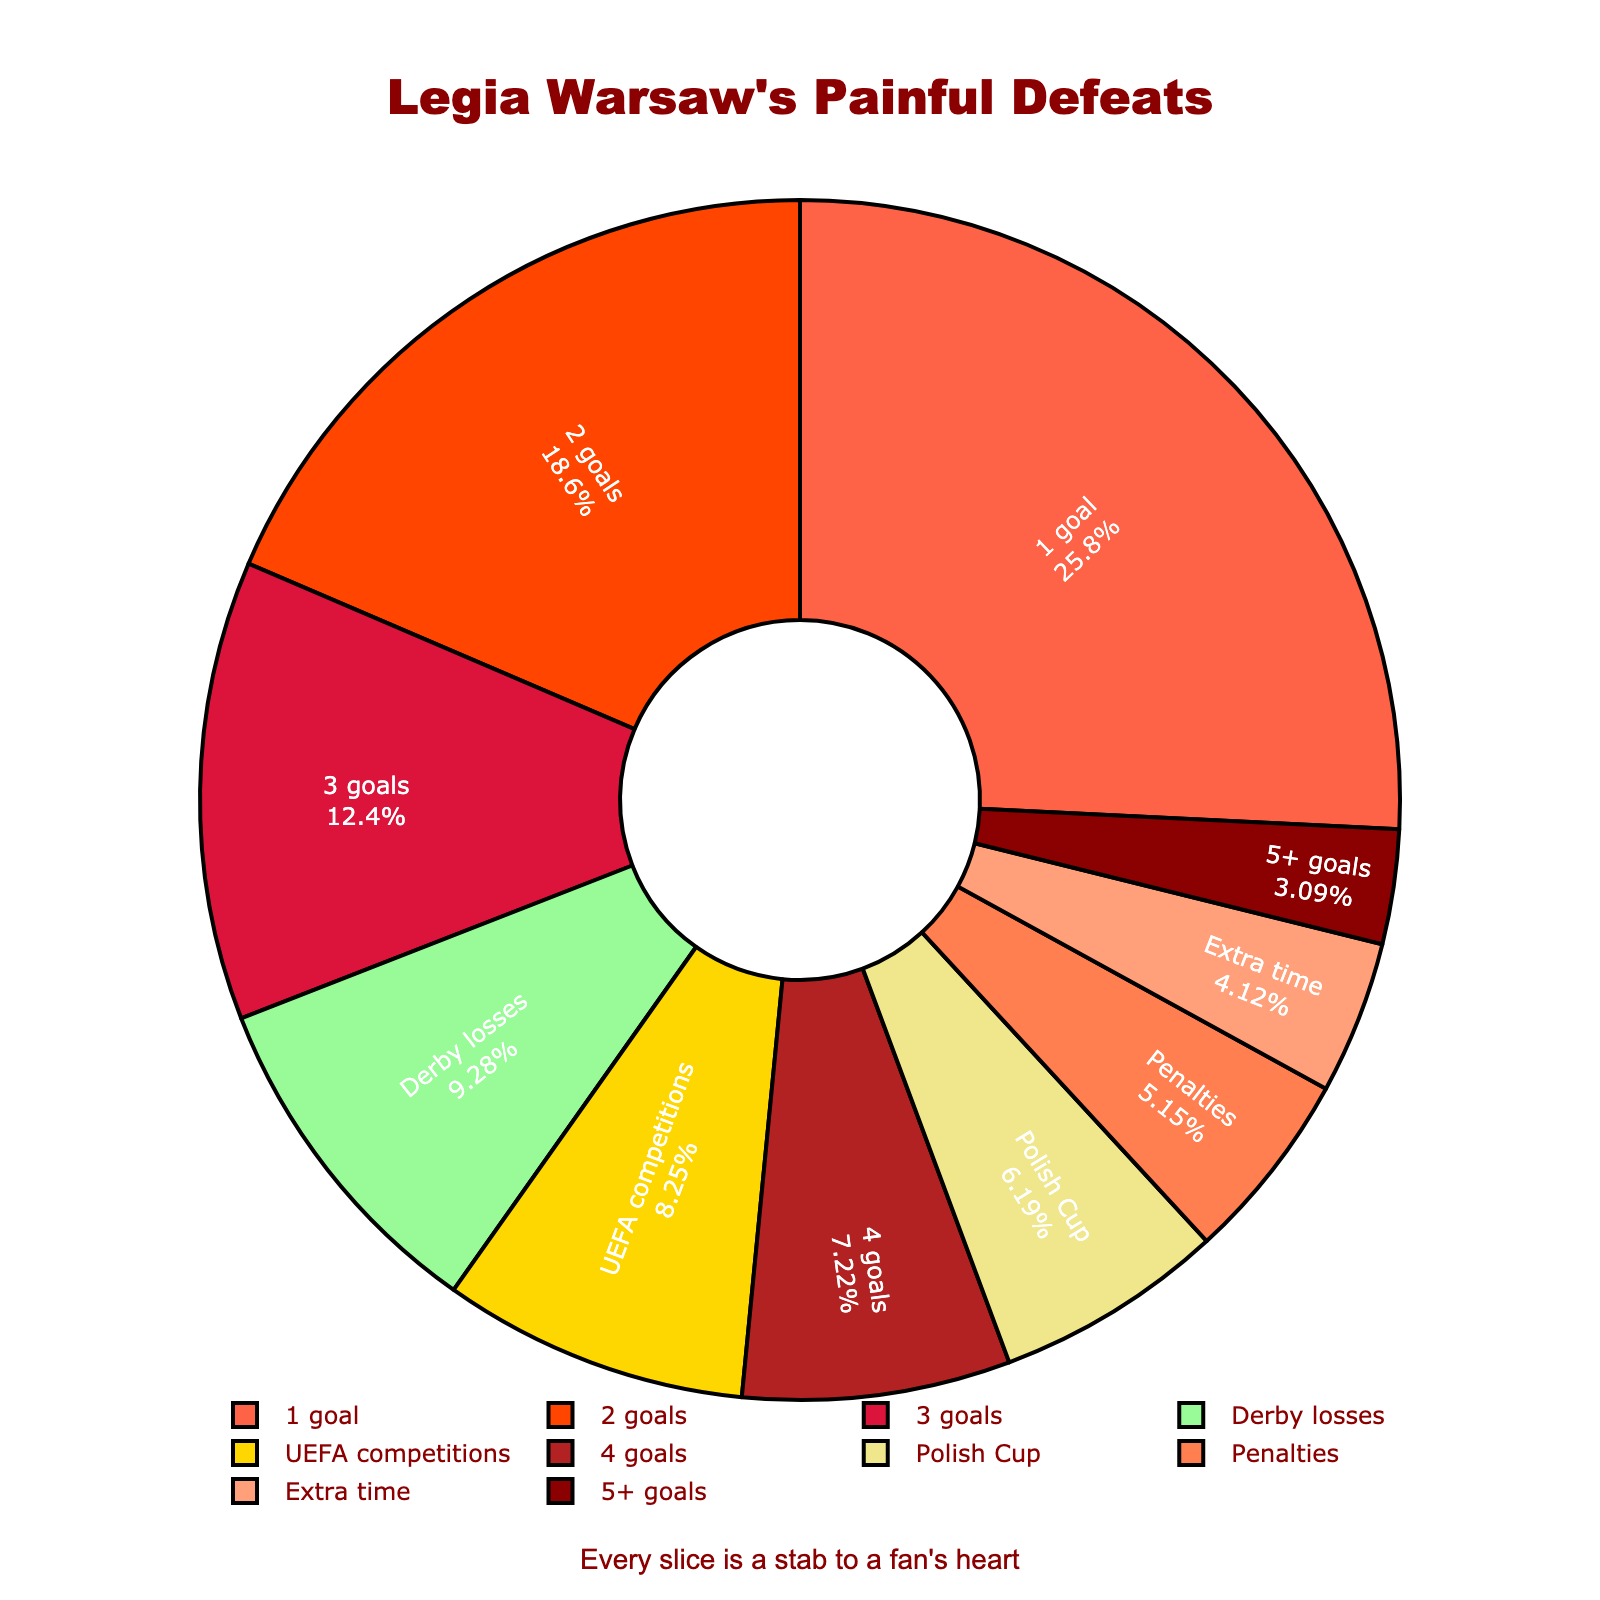What percentage of Legia Warsaw's worst losses were by a margin of 2 goals? The pie chart displays the number of losses and their corresponding percentages. Look for the label "2 goals" and read the percentage directly from the chart.
Answer: 21.2% How many more 1-goal defeats does Legia Warsaw have compared to losses by penalties? Find the number of 1-goal losses (25) and losses by penalties (5). Subtract the number of losses by penalties from the 1-goal losses: 25 - 5 = 20.
Answer: 20 Which category has the smallest number of losses and what is the color associated with it? Identify the category with the smallest portion in the pie chart. The smallest section represents "5+ goals" with 3 losses. The color associated with it is the darkest shade.
Answer: 5+ goals, dark red What is the combined percentage of losses in extra time and by penalties? Add the percentages of losses in extra time (8.3%) and by penalties (11.8%). Total: 8.3% + 11.8% = 20.1%.
Answer: 20.1% Are there more defeats in UEFA competitions or Polish Cup, and by how many? Compare the number of losses in UEFA competitions (8) and Polish Cup (6). Subtract the number of Polish Cup losses from UEFA competition losses: 8 - 6 = 2.
Answer: UEFA competitions, by 2 What portion of the total is attributed to losses with a margin of 3 goals or more? Sum the number of losses under the categories "3 goals," "4 goals," and "5+ goals". 3 goals (12) + 4 goals (7) + 5+ goals (3) = 22. Calculate the percentage: 22 / 97 total losses = 22.68%.
Answer: 22.68% Which category has exactly 10% of the total losses, and what margin does it represent? Identify the category that the pie chart shows as 10%. The segment representing "Derby losses" fits this criterion.
Answer: Derby losses How does the number of 1-goal defeats compare visually to the number of defeats by 3 goals? Estimate the size of the pie chart slices. The 1-goal defeat section is more significant and takes up a larger area compared to the 3-goal defeat section.
Answer: Larger What is the difference in percentage between defeats by 4 goals and by 2 goals? Subtract the percentage of 4-goal defeats (7.2%) from 2-goal defeats (21.2%). 21.2% - 7.2% = 14%.
Answer: 14% Is the percentage of derby losses greater or lesser than losses in UEFA competitions? Compare the percentage of derby losses (9.3%) to UEFA competition losses (8.3%). The percentage of derby losses is slightly higher.
Answer: Greater 